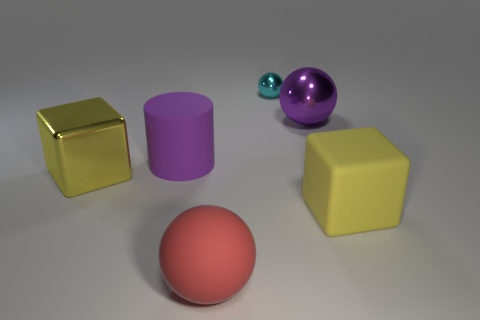There is a yellow thing that is on the right side of the large object behind the big purple matte thing; what is its shape?
Offer a very short reply. Cube. Are there any other things that have the same color as the small shiny ball?
Make the answer very short. No. Is there any other thing that is the same size as the cyan metal ball?
Offer a terse response. No. How many things are rubber cubes or cylinders?
Provide a succinct answer. 2. Are there any blue metallic cylinders that have the same size as the red object?
Provide a succinct answer. No. The yellow metallic thing has what shape?
Ensure brevity in your answer.  Cube. Are there more big purple objects that are to the right of the red sphere than big rubber blocks that are behind the large purple shiny ball?
Provide a short and direct response. Yes. Is the color of the large thing left of the purple cylinder the same as the rubber cube in front of the big metallic sphere?
Provide a succinct answer. Yes. There is a red matte object that is the same size as the yellow matte cube; what shape is it?
Your response must be concise. Sphere. Are there any other yellow metallic objects of the same shape as the large yellow metal thing?
Ensure brevity in your answer.  No. 